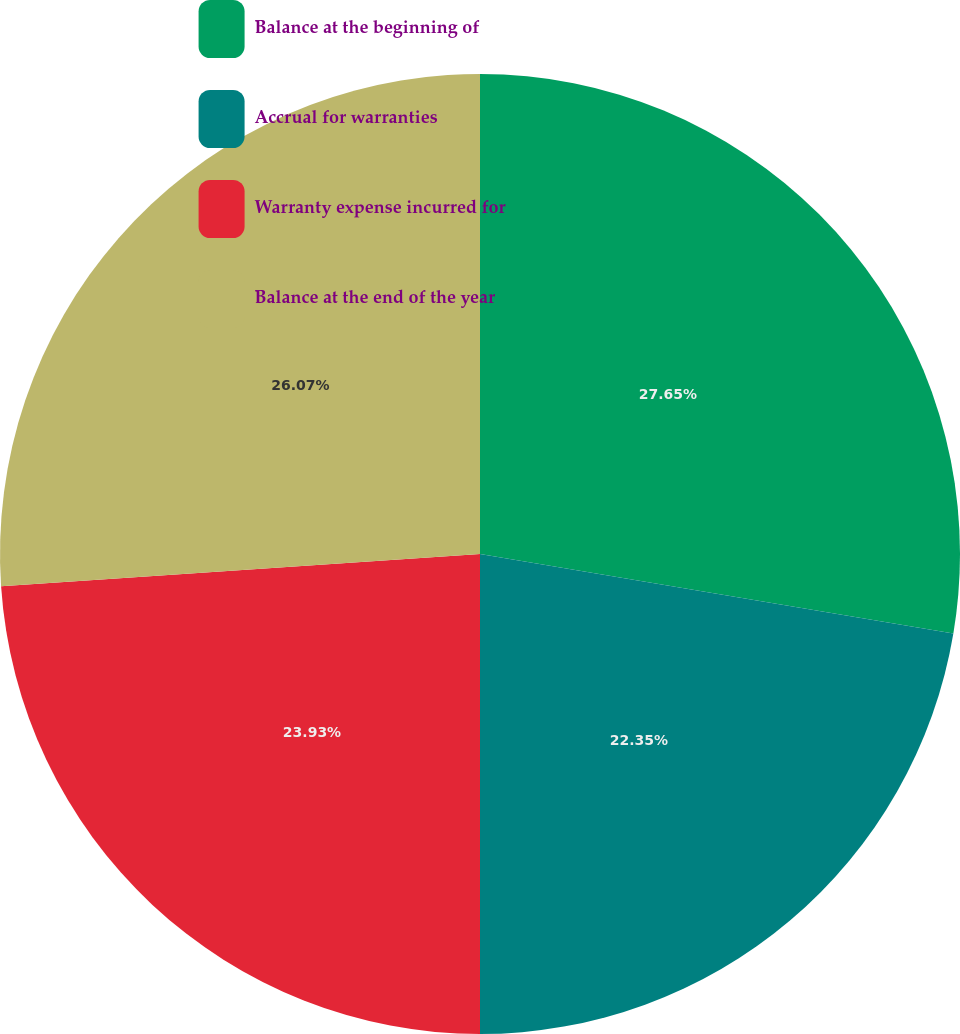Convert chart to OTSL. <chart><loc_0><loc_0><loc_500><loc_500><pie_chart><fcel>Balance at the beginning of<fcel>Accrual for warranties<fcel>Warranty expense incurred for<fcel>Balance at the end of the year<nl><fcel>27.65%<fcel>22.35%<fcel>23.93%<fcel>26.07%<nl></chart> 